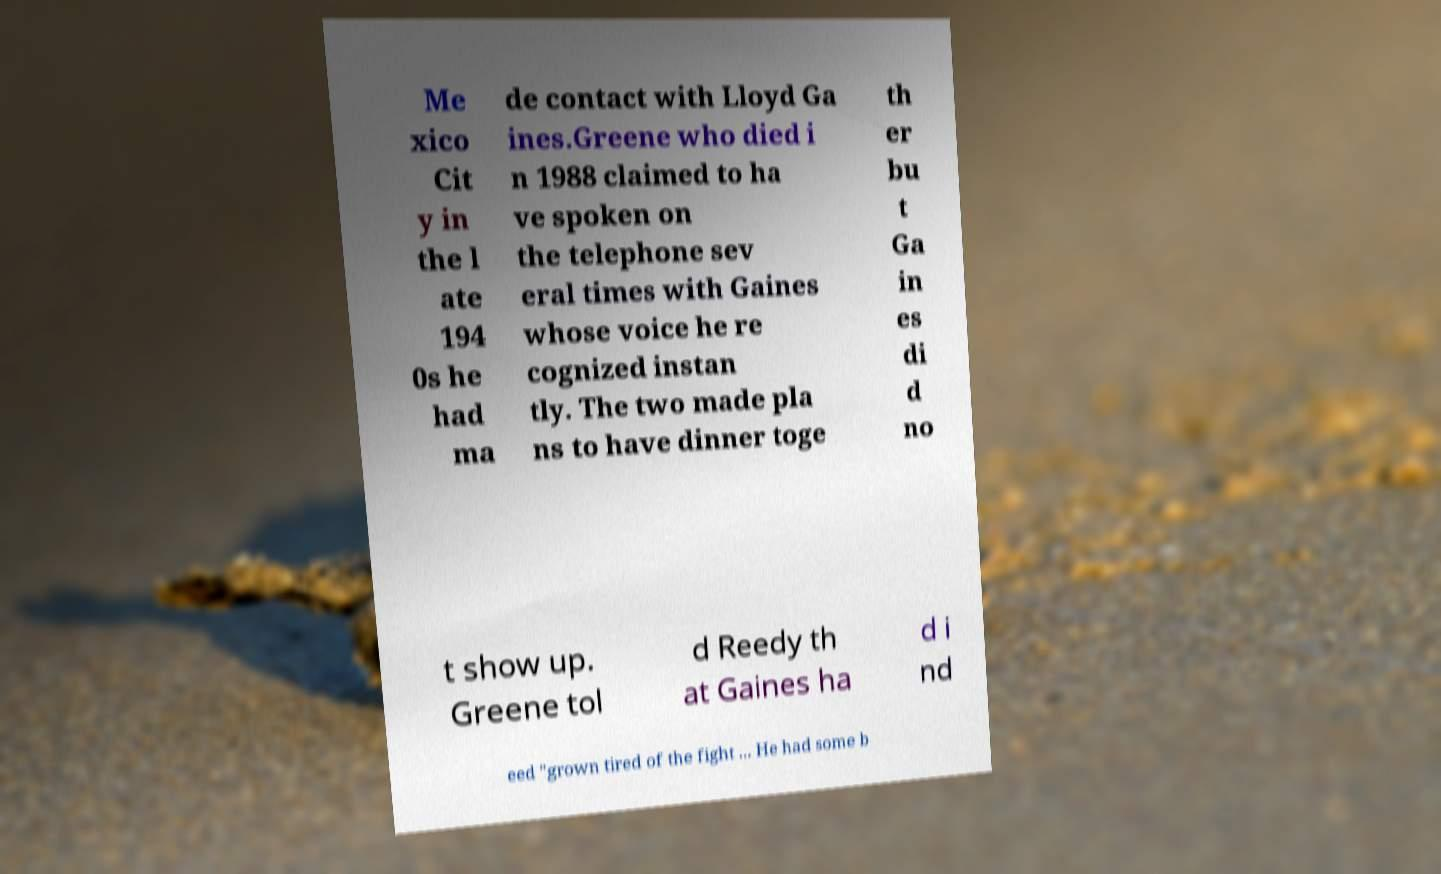Can you accurately transcribe the text from the provided image for me? Me xico Cit y in the l ate 194 0s he had ma de contact with Lloyd Ga ines.Greene who died i n 1988 claimed to ha ve spoken on the telephone sev eral times with Gaines whose voice he re cognized instan tly. The two made pla ns to have dinner toge th er bu t Ga in es di d no t show up. Greene tol d Reedy th at Gaines ha d i nd eed "grown tired of the fight ... He had some b 